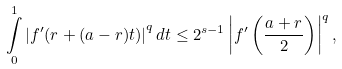<formula> <loc_0><loc_0><loc_500><loc_500>\underset { 0 } { \overset { 1 } { \int } } \left | f ^ { \prime } ( r + ( a - r ) t ) \right | ^ { q } d t \leq 2 ^ { s - 1 } \left | f ^ { \prime } \left ( \frac { a + r } { 2 } \right ) \right | ^ { q } ,</formula> 